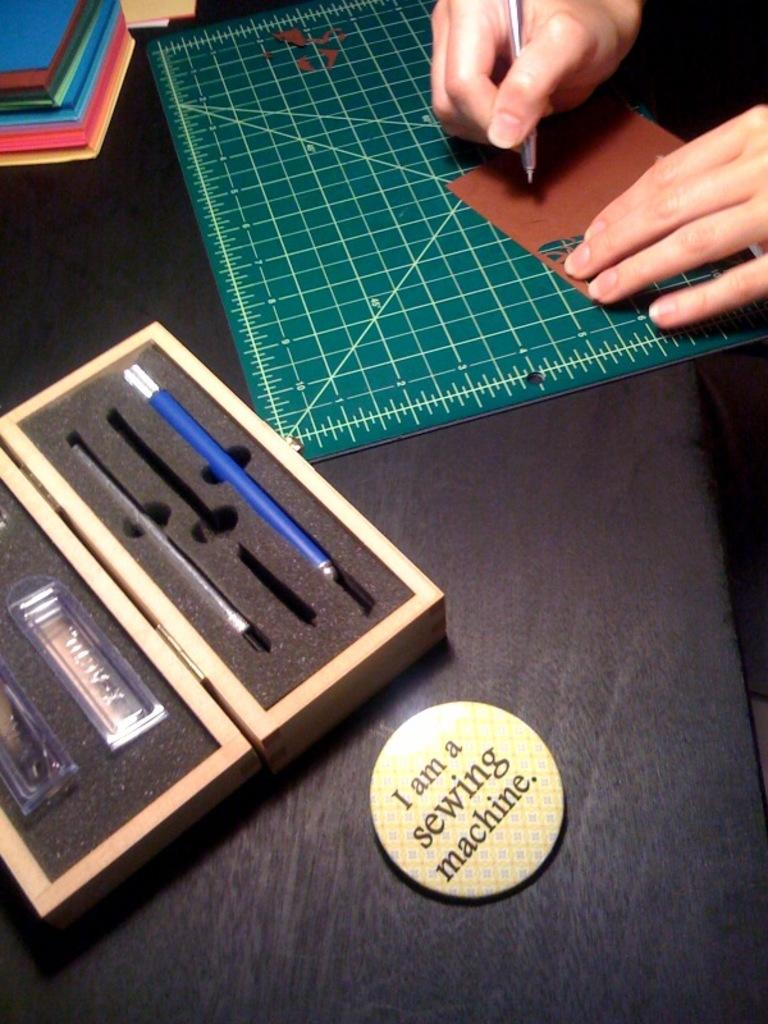<image>
Share a concise interpretation of the image provided. A button sitting on a drafting table claims itself to be a sewing machine. 